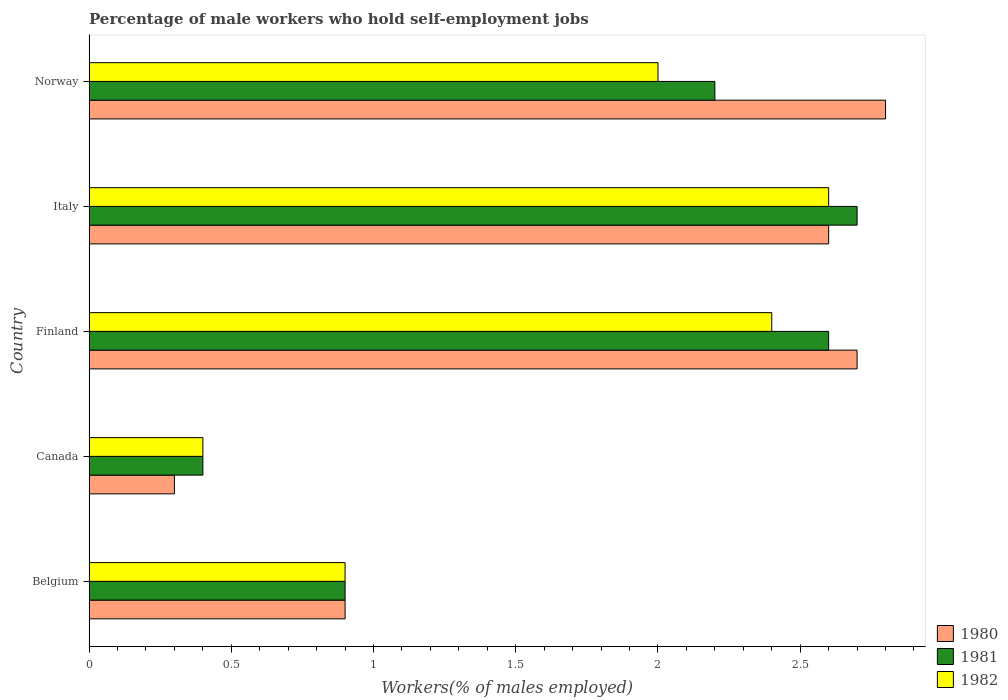How many bars are there on the 4th tick from the top?
Offer a terse response. 3. How many bars are there on the 4th tick from the bottom?
Your answer should be very brief. 3. What is the label of the 1st group of bars from the top?
Provide a short and direct response. Norway. In how many cases, is the number of bars for a given country not equal to the number of legend labels?
Your response must be concise. 0. What is the percentage of self-employed male workers in 1982 in Finland?
Make the answer very short. 2.4. Across all countries, what is the maximum percentage of self-employed male workers in 1982?
Provide a short and direct response. 2.6. Across all countries, what is the minimum percentage of self-employed male workers in 1982?
Give a very brief answer. 0.4. In which country was the percentage of self-employed male workers in 1981 maximum?
Keep it short and to the point. Italy. In which country was the percentage of self-employed male workers in 1981 minimum?
Make the answer very short. Canada. What is the total percentage of self-employed male workers in 1981 in the graph?
Offer a very short reply. 8.8. What is the difference between the percentage of self-employed male workers in 1980 in Canada and that in Finland?
Your answer should be very brief. -2.4. What is the difference between the percentage of self-employed male workers in 1980 in Italy and the percentage of self-employed male workers in 1981 in Norway?
Your response must be concise. 0.4. What is the average percentage of self-employed male workers in 1982 per country?
Offer a terse response. 1.66. In how many countries, is the percentage of self-employed male workers in 1981 greater than 2.1 %?
Make the answer very short. 3. What is the ratio of the percentage of self-employed male workers in 1982 in Belgium to that in Canada?
Your answer should be very brief. 2.25. Is the percentage of self-employed male workers in 1982 in Belgium less than that in Finland?
Your answer should be compact. Yes. Is the difference between the percentage of self-employed male workers in 1982 in Belgium and Canada greater than the difference between the percentage of self-employed male workers in 1981 in Belgium and Canada?
Your answer should be very brief. No. What is the difference between the highest and the second highest percentage of self-employed male workers in 1980?
Your response must be concise. 0.1. What is the difference between the highest and the lowest percentage of self-employed male workers in 1981?
Offer a very short reply. 2.3. In how many countries, is the percentage of self-employed male workers in 1982 greater than the average percentage of self-employed male workers in 1982 taken over all countries?
Your response must be concise. 3. What does the 2nd bar from the top in Canada represents?
Provide a succinct answer. 1981. Is it the case that in every country, the sum of the percentage of self-employed male workers in 1980 and percentage of self-employed male workers in 1981 is greater than the percentage of self-employed male workers in 1982?
Provide a succinct answer. Yes. How many bars are there?
Make the answer very short. 15. Are all the bars in the graph horizontal?
Provide a succinct answer. Yes. How many countries are there in the graph?
Make the answer very short. 5. Are the values on the major ticks of X-axis written in scientific E-notation?
Your response must be concise. No. Does the graph contain any zero values?
Give a very brief answer. No. What is the title of the graph?
Provide a short and direct response. Percentage of male workers who hold self-employment jobs. What is the label or title of the X-axis?
Provide a short and direct response. Workers(% of males employed). What is the label or title of the Y-axis?
Your answer should be very brief. Country. What is the Workers(% of males employed) of 1980 in Belgium?
Provide a succinct answer. 0.9. What is the Workers(% of males employed) of 1981 in Belgium?
Your answer should be very brief. 0.9. What is the Workers(% of males employed) in 1982 in Belgium?
Your answer should be very brief. 0.9. What is the Workers(% of males employed) of 1980 in Canada?
Make the answer very short. 0.3. What is the Workers(% of males employed) in 1981 in Canada?
Your answer should be compact. 0.4. What is the Workers(% of males employed) of 1982 in Canada?
Keep it short and to the point. 0.4. What is the Workers(% of males employed) of 1980 in Finland?
Ensure brevity in your answer.  2.7. What is the Workers(% of males employed) in 1981 in Finland?
Keep it short and to the point. 2.6. What is the Workers(% of males employed) in 1982 in Finland?
Your response must be concise. 2.4. What is the Workers(% of males employed) of 1980 in Italy?
Provide a short and direct response. 2.6. What is the Workers(% of males employed) of 1981 in Italy?
Keep it short and to the point. 2.7. What is the Workers(% of males employed) in 1982 in Italy?
Make the answer very short. 2.6. What is the Workers(% of males employed) in 1980 in Norway?
Offer a very short reply. 2.8. What is the Workers(% of males employed) of 1981 in Norway?
Your answer should be compact. 2.2. What is the Workers(% of males employed) in 1982 in Norway?
Your response must be concise. 2. Across all countries, what is the maximum Workers(% of males employed) of 1980?
Provide a short and direct response. 2.8. Across all countries, what is the maximum Workers(% of males employed) of 1981?
Offer a very short reply. 2.7. Across all countries, what is the maximum Workers(% of males employed) of 1982?
Ensure brevity in your answer.  2.6. Across all countries, what is the minimum Workers(% of males employed) in 1980?
Ensure brevity in your answer.  0.3. Across all countries, what is the minimum Workers(% of males employed) of 1981?
Your response must be concise. 0.4. Across all countries, what is the minimum Workers(% of males employed) in 1982?
Your answer should be very brief. 0.4. What is the total Workers(% of males employed) in 1981 in the graph?
Keep it short and to the point. 8.8. What is the difference between the Workers(% of males employed) in 1981 in Belgium and that in Finland?
Give a very brief answer. -1.7. What is the difference between the Workers(% of males employed) in 1980 in Belgium and that in Italy?
Keep it short and to the point. -1.7. What is the difference between the Workers(% of males employed) in 1980 in Canada and that in Finland?
Provide a succinct answer. -2.4. What is the difference between the Workers(% of males employed) in 1981 in Canada and that in Finland?
Your response must be concise. -2.2. What is the difference between the Workers(% of males employed) of 1982 in Canada and that in Finland?
Offer a very short reply. -2. What is the difference between the Workers(% of males employed) of 1982 in Canada and that in Italy?
Keep it short and to the point. -2.2. What is the difference between the Workers(% of males employed) of 1982 in Canada and that in Norway?
Provide a short and direct response. -1.6. What is the difference between the Workers(% of males employed) in 1980 in Finland and that in Italy?
Your response must be concise. 0.1. What is the difference between the Workers(% of males employed) in 1982 in Finland and that in Italy?
Your response must be concise. -0.2. What is the difference between the Workers(% of males employed) of 1982 in Finland and that in Norway?
Provide a succinct answer. 0.4. What is the difference between the Workers(% of males employed) of 1980 in Italy and that in Norway?
Provide a short and direct response. -0.2. What is the difference between the Workers(% of males employed) of 1982 in Italy and that in Norway?
Give a very brief answer. 0.6. What is the difference between the Workers(% of males employed) in 1980 in Belgium and the Workers(% of males employed) in 1981 in Finland?
Provide a short and direct response. -1.7. What is the difference between the Workers(% of males employed) of 1981 in Belgium and the Workers(% of males employed) of 1982 in Finland?
Your answer should be compact. -1.5. What is the difference between the Workers(% of males employed) in 1980 in Belgium and the Workers(% of males employed) in 1982 in Italy?
Provide a succinct answer. -1.7. What is the difference between the Workers(% of males employed) in 1981 in Belgium and the Workers(% of males employed) in 1982 in Italy?
Your response must be concise. -1.7. What is the difference between the Workers(% of males employed) of 1980 in Belgium and the Workers(% of males employed) of 1981 in Norway?
Offer a terse response. -1.3. What is the difference between the Workers(% of males employed) of 1981 in Belgium and the Workers(% of males employed) of 1982 in Norway?
Your answer should be compact. -1.1. What is the difference between the Workers(% of males employed) of 1981 in Canada and the Workers(% of males employed) of 1982 in Italy?
Your response must be concise. -2.2. What is the difference between the Workers(% of males employed) in 1980 in Canada and the Workers(% of males employed) in 1981 in Norway?
Your answer should be compact. -1.9. What is the difference between the Workers(% of males employed) in 1980 in Canada and the Workers(% of males employed) in 1982 in Norway?
Give a very brief answer. -1.7. What is the difference between the Workers(% of males employed) in 1981 in Canada and the Workers(% of males employed) in 1982 in Norway?
Offer a very short reply. -1.6. What is the difference between the Workers(% of males employed) in 1980 in Finland and the Workers(% of males employed) in 1982 in Italy?
Your answer should be compact. 0.1. What is the difference between the Workers(% of males employed) of 1981 in Finland and the Workers(% of males employed) of 1982 in Italy?
Ensure brevity in your answer.  0. What is the difference between the Workers(% of males employed) of 1980 in Finland and the Workers(% of males employed) of 1981 in Norway?
Give a very brief answer. 0.5. What is the difference between the Workers(% of males employed) of 1980 in Finland and the Workers(% of males employed) of 1982 in Norway?
Offer a very short reply. 0.7. What is the difference between the Workers(% of males employed) in 1981 in Finland and the Workers(% of males employed) in 1982 in Norway?
Offer a terse response. 0.6. What is the difference between the Workers(% of males employed) of 1980 in Italy and the Workers(% of males employed) of 1982 in Norway?
Give a very brief answer. 0.6. What is the average Workers(% of males employed) in 1980 per country?
Keep it short and to the point. 1.86. What is the average Workers(% of males employed) in 1981 per country?
Provide a succinct answer. 1.76. What is the average Workers(% of males employed) of 1982 per country?
Ensure brevity in your answer.  1.66. What is the difference between the Workers(% of males employed) in 1980 and Workers(% of males employed) in 1981 in Canada?
Provide a short and direct response. -0.1. What is the difference between the Workers(% of males employed) of 1980 and Workers(% of males employed) of 1982 in Canada?
Offer a terse response. -0.1. What is the difference between the Workers(% of males employed) in 1980 and Workers(% of males employed) in 1982 in Finland?
Provide a short and direct response. 0.3. What is the difference between the Workers(% of males employed) of 1980 and Workers(% of males employed) of 1982 in Italy?
Offer a very short reply. 0. What is the difference between the Workers(% of males employed) in 1980 and Workers(% of males employed) in 1982 in Norway?
Provide a succinct answer. 0.8. What is the difference between the Workers(% of males employed) of 1981 and Workers(% of males employed) of 1982 in Norway?
Your response must be concise. 0.2. What is the ratio of the Workers(% of males employed) in 1980 in Belgium to that in Canada?
Give a very brief answer. 3. What is the ratio of the Workers(% of males employed) in 1981 in Belgium to that in Canada?
Provide a short and direct response. 2.25. What is the ratio of the Workers(% of males employed) in 1982 in Belgium to that in Canada?
Keep it short and to the point. 2.25. What is the ratio of the Workers(% of males employed) of 1981 in Belgium to that in Finland?
Provide a short and direct response. 0.35. What is the ratio of the Workers(% of males employed) of 1980 in Belgium to that in Italy?
Make the answer very short. 0.35. What is the ratio of the Workers(% of males employed) of 1982 in Belgium to that in Italy?
Your answer should be very brief. 0.35. What is the ratio of the Workers(% of males employed) in 1980 in Belgium to that in Norway?
Your response must be concise. 0.32. What is the ratio of the Workers(% of males employed) in 1981 in Belgium to that in Norway?
Your answer should be compact. 0.41. What is the ratio of the Workers(% of males employed) of 1982 in Belgium to that in Norway?
Keep it short and to the point. 0.45. What is the ratio of the Workers(% of males employed) in 1980 in Canada to that in Finland?
Give a very brief answer. 0.11. What is the ratio of the Workers(% of males employed) in 1981 in Canada to that in Finland?
Make the answer very short. 0.15. What is the ratio of the Workers(% of males employed) in 1980 in Canada to that in Italy?
Make the answer very short. 0.12. What is the ratio of the Workers(% of males employed) of 1981 in Canada to that in Italy?
Give a very brief answer. 0.15. What is the ratio of the Workers(% of males employed) of 1982 in Canada to that in Italy?
Provide a short and direct response. 0.15. What is the ratio of the Workers(% of males employed) of 1980 in Canada to that in Norway?
Offer a terse response. 0.11. What is the ratio of the Workers(% of males employed) of 1981 in Canada to that in Norway?
Provide a short and direct response. 0.18. What is the ratio of the Workers(% of males employed) in 1980 in Finland to that in Italy?
Offer a terse response. 1.04. What is the ratio of the Workers(% of males employed) in 1981 in Finland to that in Italy?
Offer a very short reply. 0.96. What is the ratio of the Workers(% of males employed) of 1982 in Finland to that in Italy?
Provide a succinct answer. 0.92. What is the ratio of the Workers(% of males employed) of 1980 in Finland to that in Norway?
Keep it short and to the point. 0.96. What is the ratio of the Workers(% of males employed) in 1981 in Finland to that in Norway?
Your answer should be compact. 1.18. What is the ratio of the Workers(% of males employed) in 1982 in Finland to that in Norway?
Ensure brevity in your answer.  1.2. What is the ratio of the Workers(% of males employed) of 1980 in Italy to that in Norway?
Keep it short and to the point. 0.93. What is the ratio of the Workers(% of males employed) of 1981 in Italy to that in Norway?
Give a very brief answer. 1.23. What is the ratio of the Workers(% of males employed) in 1982 in Italy to that in Norway?
Provide a short and direct response. 1.3. What is the difference between the highest and the lowest Workers(% of males employed) in 1980?
Provide a succinct answer. 2.5. What is the difference between the highest and the lowest Workers(% of males employed) in 1981?
Offer a terse response. 2.3. What is the difference between the highest and the lowest Workers(% of males employed) in 1982?
Ensure brevity in your answer.  2.2. 